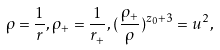Convert formula to latex. <formula><loc_0><loc_0><loc_500><loc_500>\rho = \frac { 1 } { r } , \rho _ { + } = \frac { 1 } { r _ { + } } , ( \frac { \rho _ { + } } { \rho } ) ^ { z _ { 0 } + 3 } = u ^ { 2 } ,</formula> 